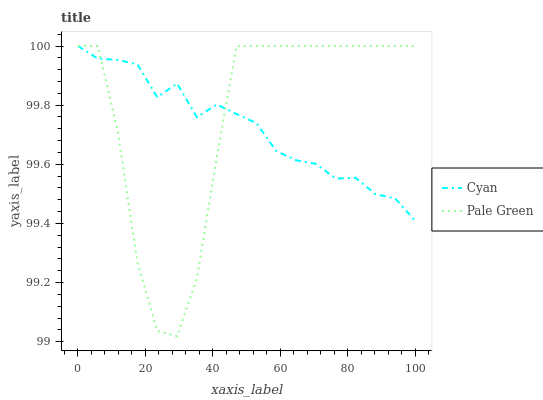Does Cyan have the minimum area under the curve?
Answer yes or no. Yes. Does Pale Green have the maximum area under the curve?
Answer yes or no. Yes. Does Pale Green have the minimum area under the curve?
Answer yes or no. No. Is Cyan the smoothest?
Answer yes or no. Yes. Is Pale Green the roughest?
Answer yes or no. Yes. Is Pale Green the smoothest?
Answer yes or no. No. Does Pale Green have the lowest value?
Answer yes or no. Yes. Does Pale Green have the highest value?
Answer yes or no. Yes. Does Cyan intersect Pale Green?
Answer yes or no. Yes. Is Cyan less than Pale Green?
Answer yes or no. No. Is Cyan greater than Pale Green?
Answer yes or no. No. 